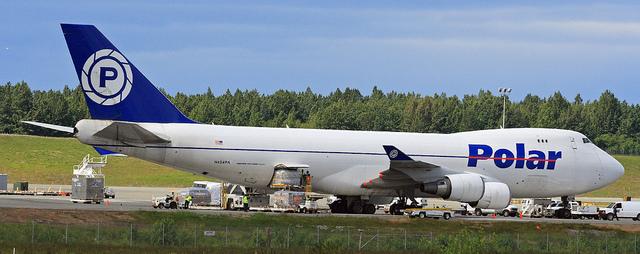Are there any vehicles around the plane?
Write a very short answer. Yes. Is the plane in motion?
Short answer required. No. What kind of vehicle is this?
Answer briefly. Airplane. 